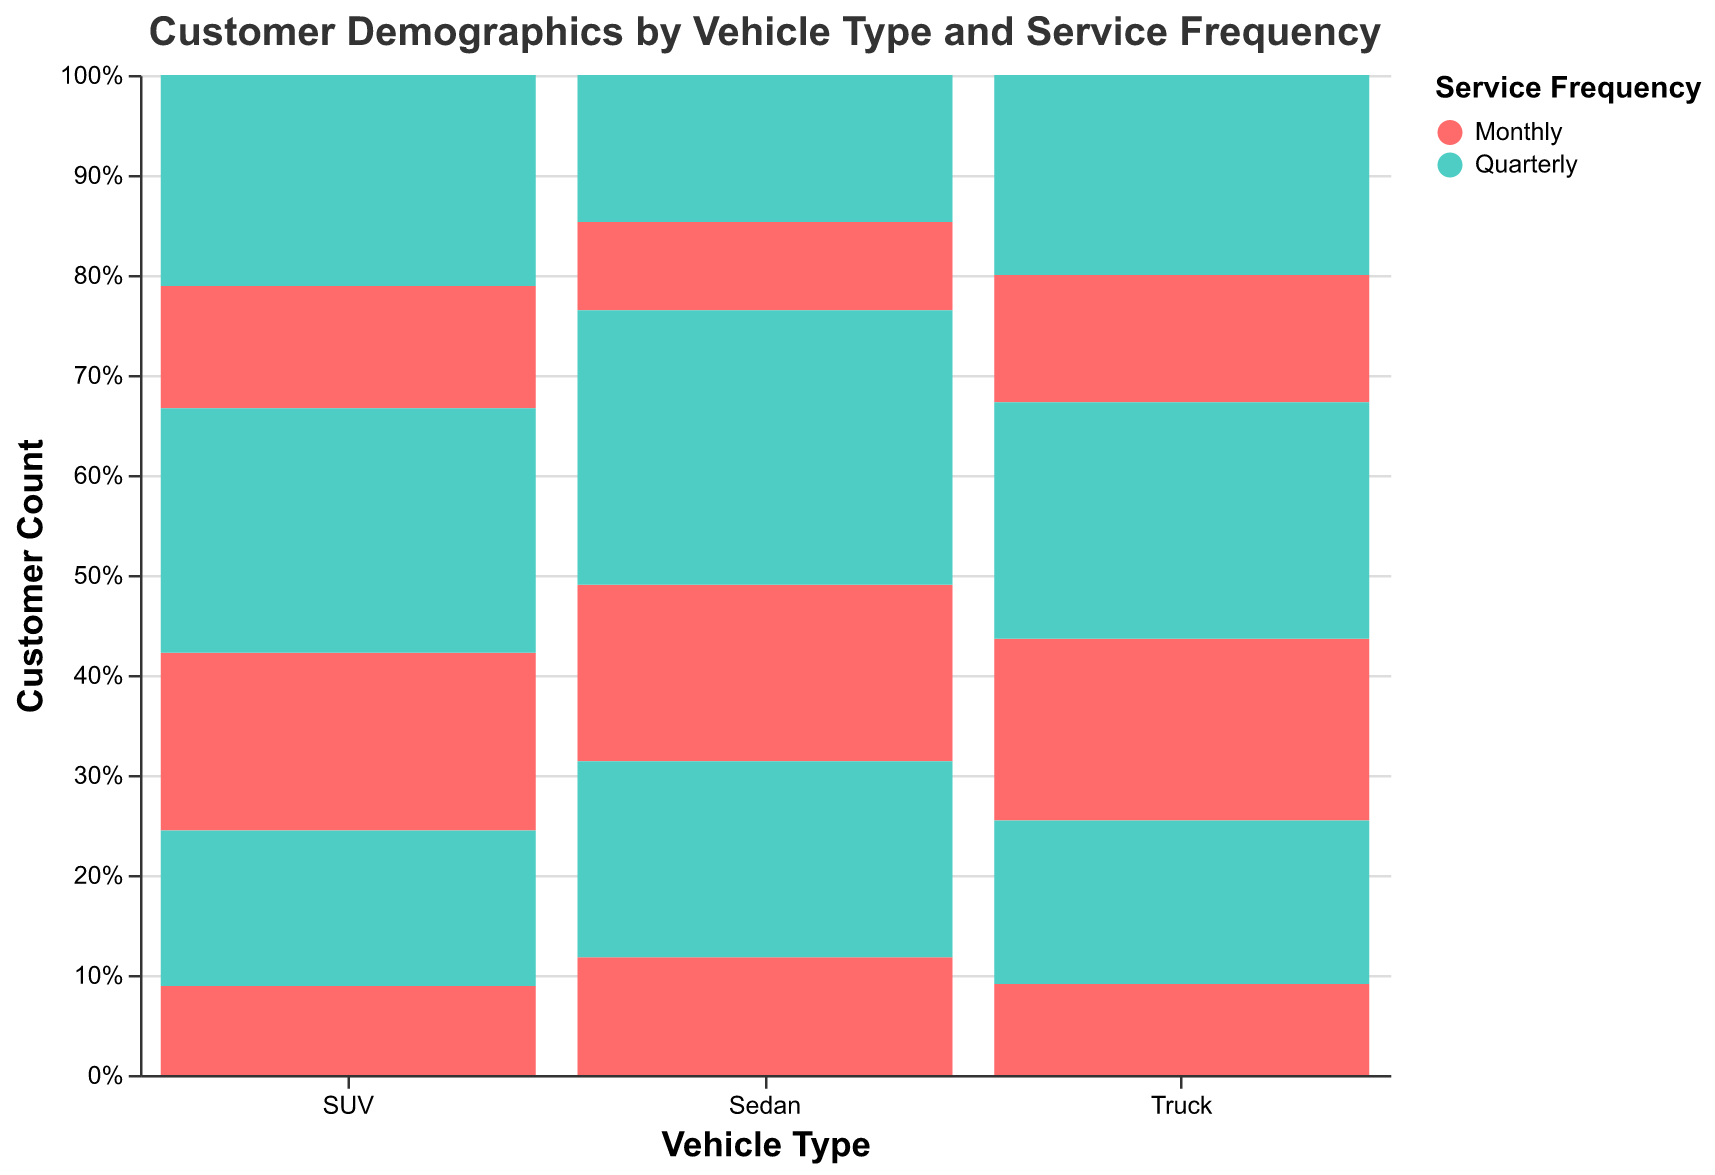What is the title of the figure? The title of the figure is located at the top.
Answer: Customer Demographics by Vehicle Type and Service Frequency Which vehicle type has the highest number of monthly customers aged 31-50? Look at the height of the "Monthly" (red) section for the 31-50 age group across different vehicle types and identify the tallest bar.
Answer: Sedan Which vehicle type has more quarterly customers, SUV or Truck? Compare the sum of the "Quarterly" (green) bar heights for SUVs and Trucks.
Answer: SUV How many customers aged 18-30 service their Sedan quarterly? Locate the "Sedan" category, find the "Quarterly" (green) section, and read the number for the 18-30 age group.
Answer: 200 Compare the number of monthly customers aged 51+ between Sedans and SUVs. Which one is higher? Look at the heights of the "Monthly" (red) sections for the 51+ age group for both Sedans and SUVs and compare.
Answer: SUV What is the total number of customers who service their Trucks monthly, across all age groups? Sum the customer counts for all age groups in the "Monthly" (red) section for Trucks.
Answer: 220 What is the predominant service frequency for customers aged 31-50 who drive Trucks? Compare the heights of the "Monthly" (red) and "Quarterly" (green) bars for the 31-50 age group in Trucks and identify the taller bar.
Answer: Quarterly How does the number of quarterly customers aged 51+ compare between Sedans and SUVs? Compare the heights of the "Quarterly" (green) bars for the 51+ age group between Sedans and SUVs.
Answer: SUV is higher Which age group has the lowest number of monthly customers for SUVs? Identify the shortest "Monthly" (red) bar in the SUV category and note the corresponding age group.
Answer: 18-30 What's the average number of customers aged 18-30 who service their vehicles quarterly across all vehicle types? Add the quarterly customer counts for the 18-30 age group from all vehicle types and divide by 3. (200 for Sedan, 140 for SUV, and 90 for Trucks)
Answer: 143.3 